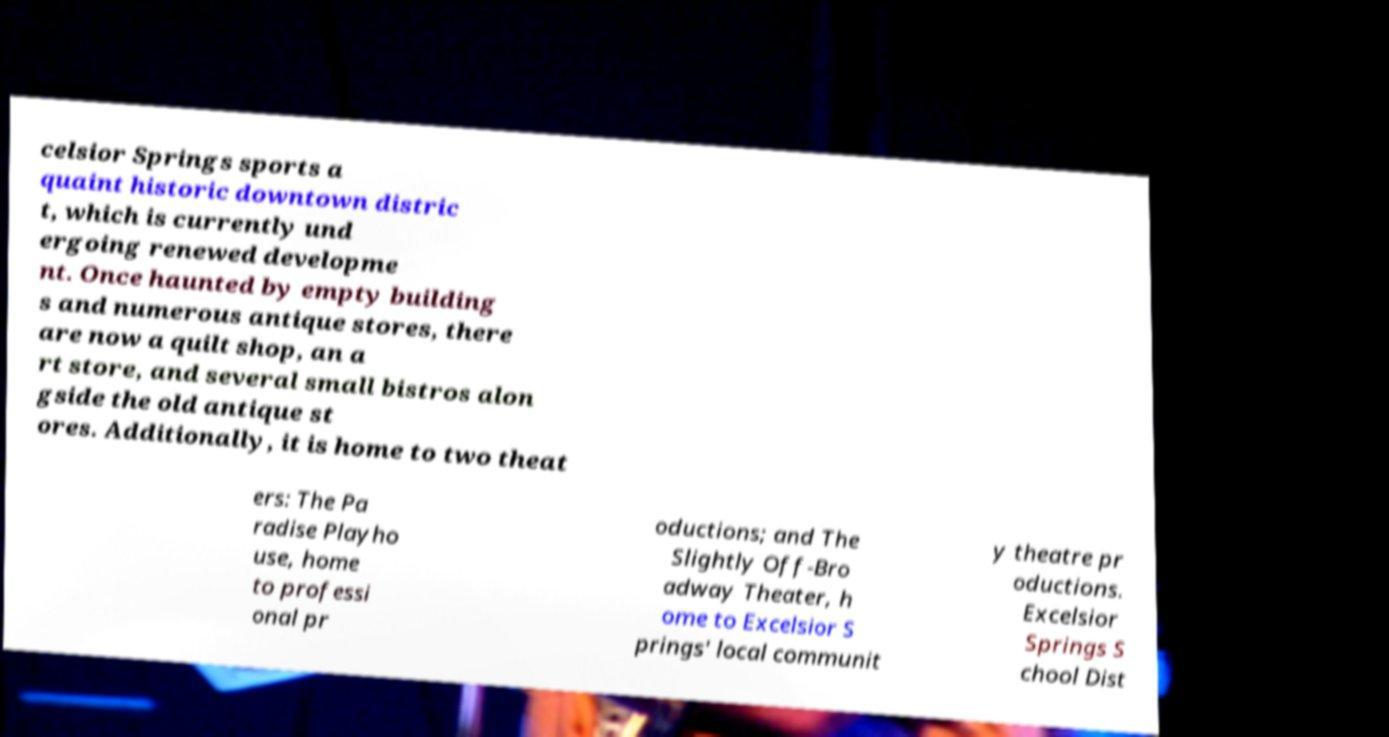Can you accurately transcribe the text from the provided image for me? celsior Springs sports a quaint historic downtown distric t, which is currently und ergoing renewed developme nt. Once haunted by empty building s and numerous antique stores, there are now a quilt shop, an a rt store, and several small bistros alon gside the old antique st ores. Additionally, it is home to two theat ers: The Pa radise Playho use, home to professi onal pr oductions; and The Slightly Off-Bro adway Theater, h ome to Excelsior S prings' local communit y theatre pr oductions. Excelsior Springs S chool Dist 